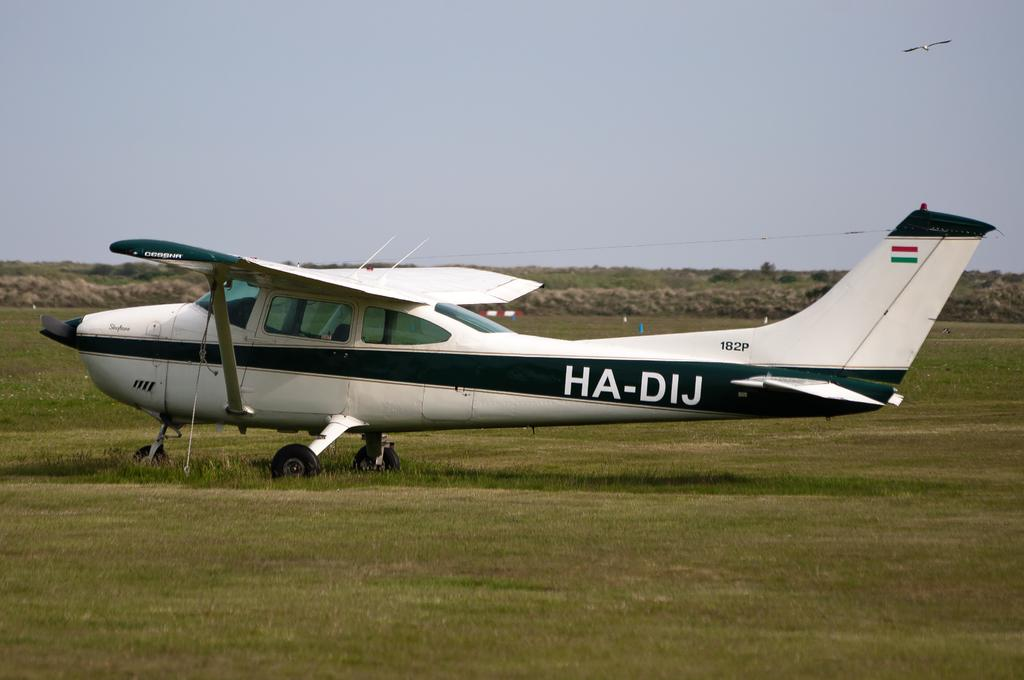What is the main subject in the center of the image? There is an aeroplane in the center of the image. What can be seen in the background of the image? There are hills in the background of the image. What is present on the ground in the image? There are objects on the ground in the image. What is flying in the sky at the top of the image? There is a bird flying in the sky at the top of the image. Where is the snake hiding in the image? There is no snake present in the image. What type of jar can be seen on the stage in the image? There is no stage or jar present in the image. 